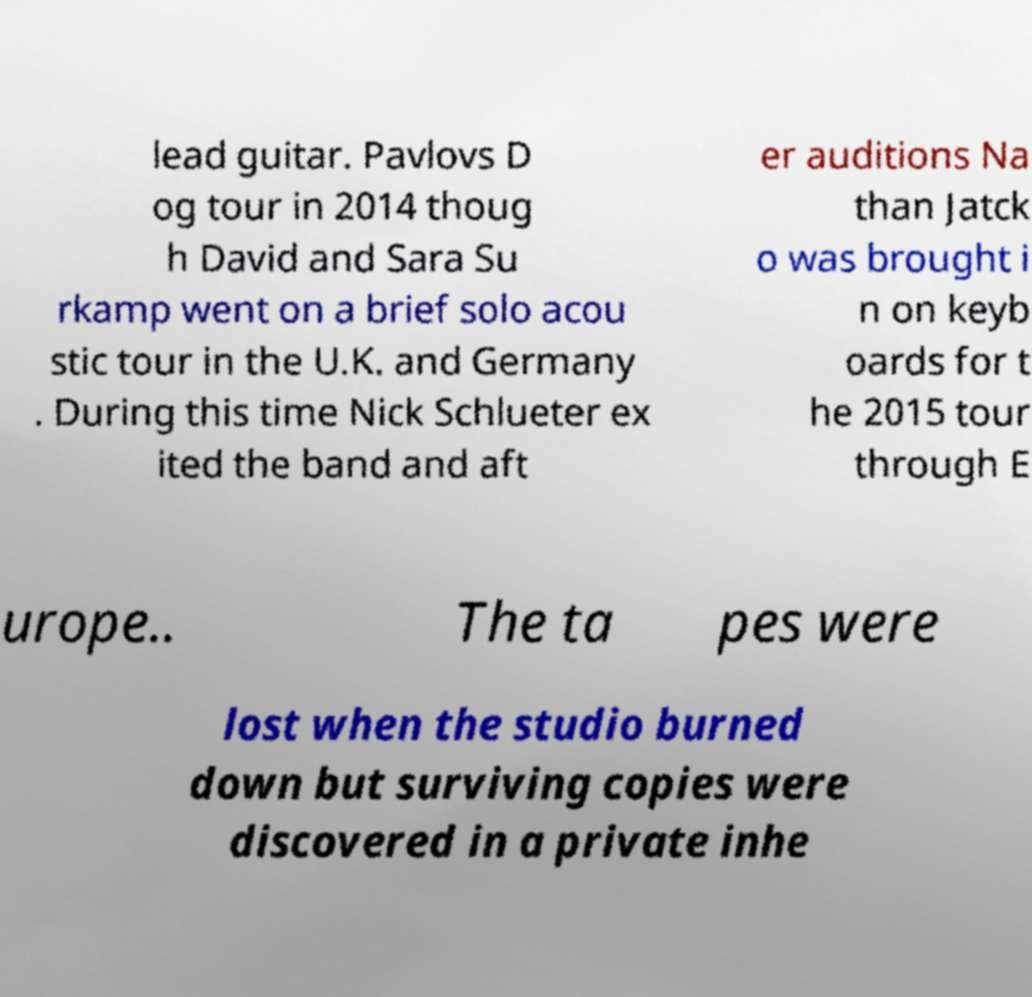Please read and relay the text visible in this image. What does it say? lead guitar. Pavlovs D og tour in 2014 thoug h David and Sara Su rkamp went on a brief solo acou stic tour in the U.K. and Germany . During this time Nick Schlueter ex ited the band and aft er auditions Na than Jatck o was brought i n on keyb oards for t he 2015 tour through E urope.. The ta pes were lost when the studio burned down but surviving copies were discovered in a private inhe 